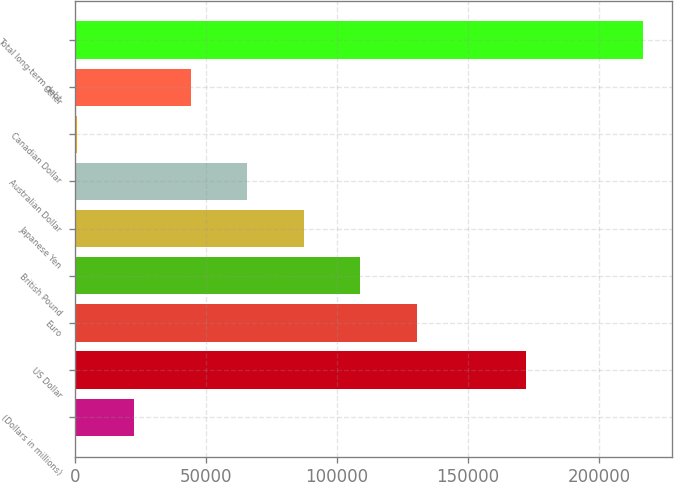Convert chart to OTSL. <chart><loc_0><loc_0><loc_500><loc_500><bar_chart><fcel>(Dollars in millions)<fcel>US Dollar<fcel>Euro<fcel>British Pound<fcel>Japanese Yen<fcel>Australian Dollar<fcel>Canadian Dollar<fcel>Other<fcel>Total long-term debt<nl><fcel>22626.4<fcel>172082<fcel>130513<fcel>108936<fcel>87358.6<fcel>65781.2<fcel>1049<fcel>44203.8<fcel>216823<nl></chart> 